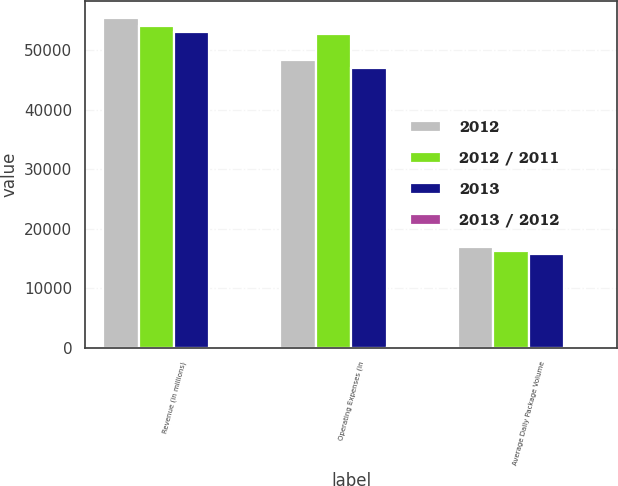Convert chart. <chart><loc_0><loc_0><loc_500><loc_500><stacked_bar_chart><ecel><fcel>Revenue (in millions)<fcel>Operating Expenses (in<fcel>Average Daily Package Volume<nl><fcel>2012<fcel>55438<fcel>48404<fcel>16938<nl><fcel>2012 / 2011<fcel>54127<fcel>52784<fcel>16295<nl><fcel>2013<fcel>53105<fcel>47025<fcel>15797<nl><fcel>2013 / 2012<fcel>2.4<fcel>8.3<fcel>3.9<nl></chart> 